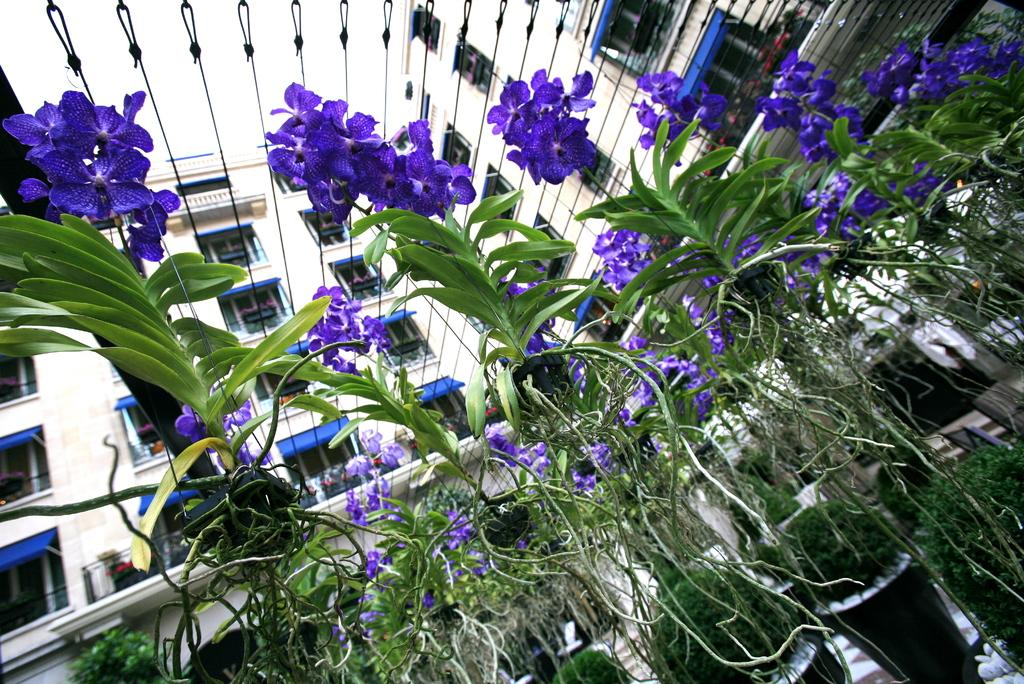What type of flowers can be seen in the image? There are purple flowers in the image. What are the purple flowers placed in? There are flower pots in the image. What other plant features can be seen in the image? There are green leaves in the image. What can be seen in the background of the image? There are buildings and windows visible in the background. What type of canvas can be seen in the image? There is no canvas present in the image. 